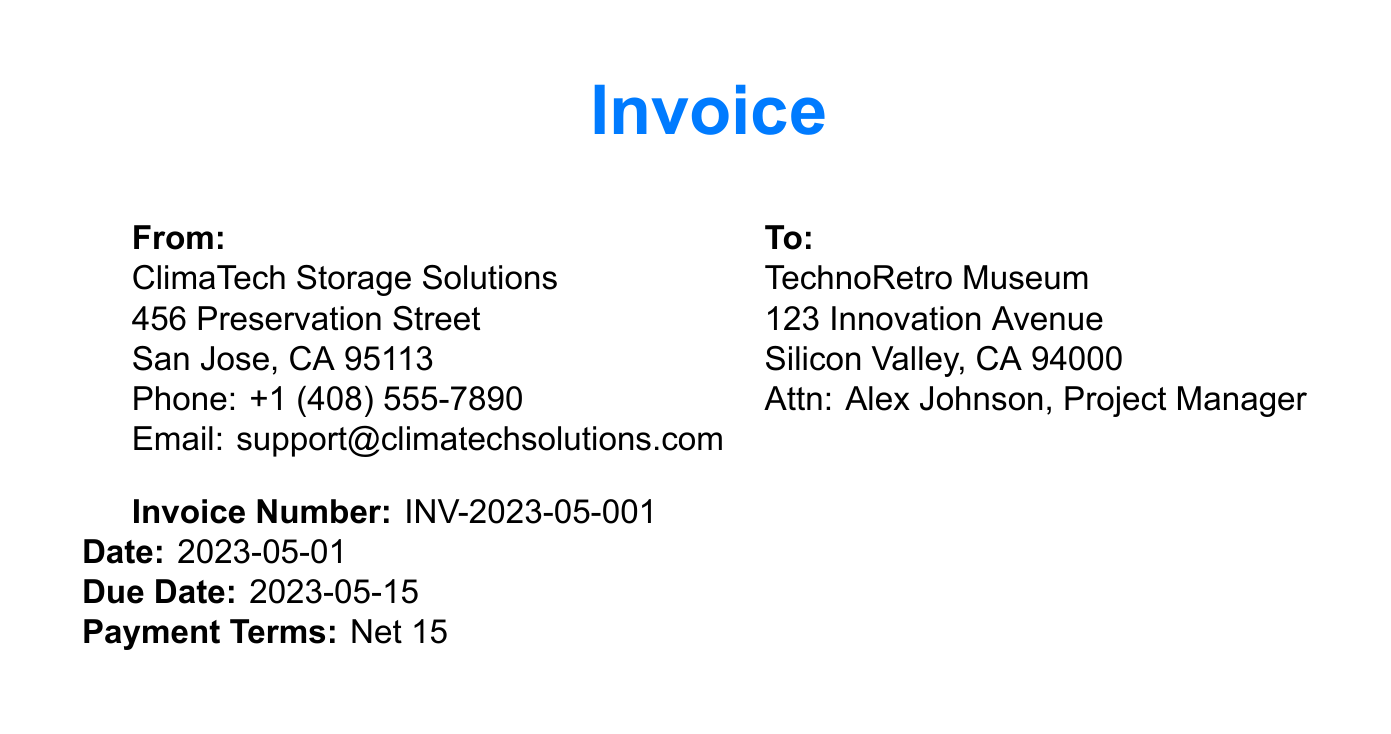What is the invoice number? The invoice number is listed in the document details section as a unique identifier for this invoice.
Answer: INV-2023-05-001 When is the due date? The due date is specified in the invoice details and indicates when the payment should be made.
Answer: 2023-05-15 How many climate-controlled storage units are rented? The quantity of climate-controlled storage units is given in the invoice items section.
Answer: 5 What is the total amount? The total amount represents the sum of all invoice items and is presented at the end of the invoice.
Answer: $1,875.00 Who is the contact person for TechnoRetro Museum? The contact person is listed under the client information for communication purposes.
Answer: Alex Johnson What service is performed by Orkin? The specific service provided by Orkin is mentioned in the invoice items section regarding pest control.
Answer: Pest control service How many dehumidifiers are maintained? The quantity of dehumidifiers listed shows how many are included in the maintenance contract.
Answer: 2 What is the unit price for environmental monitoring system maintenance? The unit price for this specific service is detailed in the invoice items section under unit price.
Answer: $225.00 What does the note at the end of the invoice state about service standards? The note specifies the adherence to specific standards for preservation conditions.
Answer: IEEE and JEDEC standards 